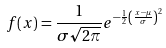Convert formula to latex. <formula><loc_0><loc_0><loc_500><loc_500>f ( x ) = { \frac { 1 } { \sigma { \sqrt { 2 \pi } } } } e ^ { - { \frac { 1 } { 2 } } \left ( { \frac { x - \mu } { \sigma } } \right ) ^ { 2 } }</formula> 